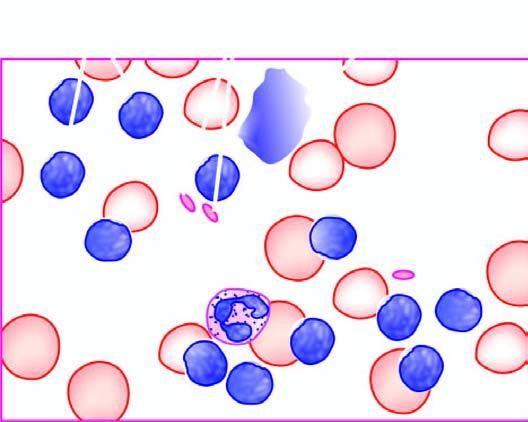s there large excess of mature and small differentiated lymphocytes?
Answer the question using a single word or phrase. Yes 